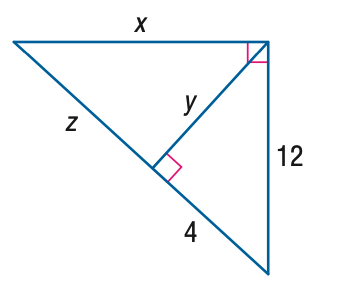Answer the mathemtical geometry problem and directly provide the correct option letter.
Question: Find x.
Choices: A: 24 B: 24 \sqrt { 2 } C: 36 D: 24 \sqrt { 3 } B 